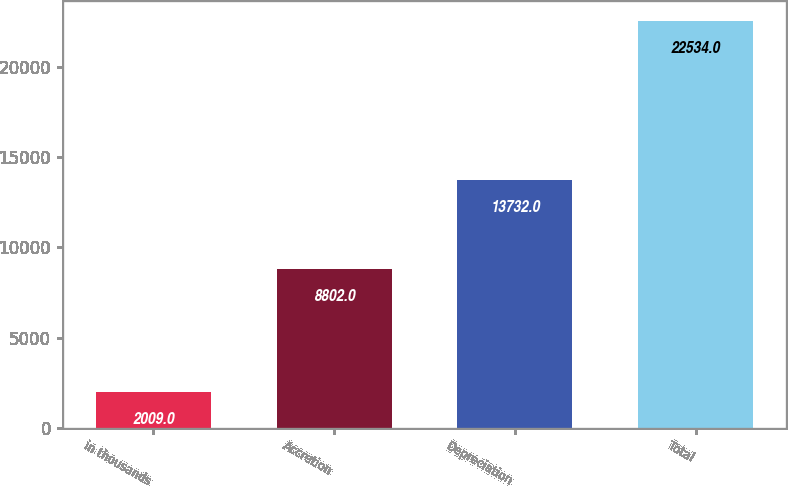<chart> <loc_0><loc_0><loc_500><loc_500><bar_chart><fcel>in thousands<fcel>Accretion<fcel>Depreciation<fcel>Total<nl><fcel>2009<fcel>8802<fcel>13732<fcel>22534<nl></chart> 